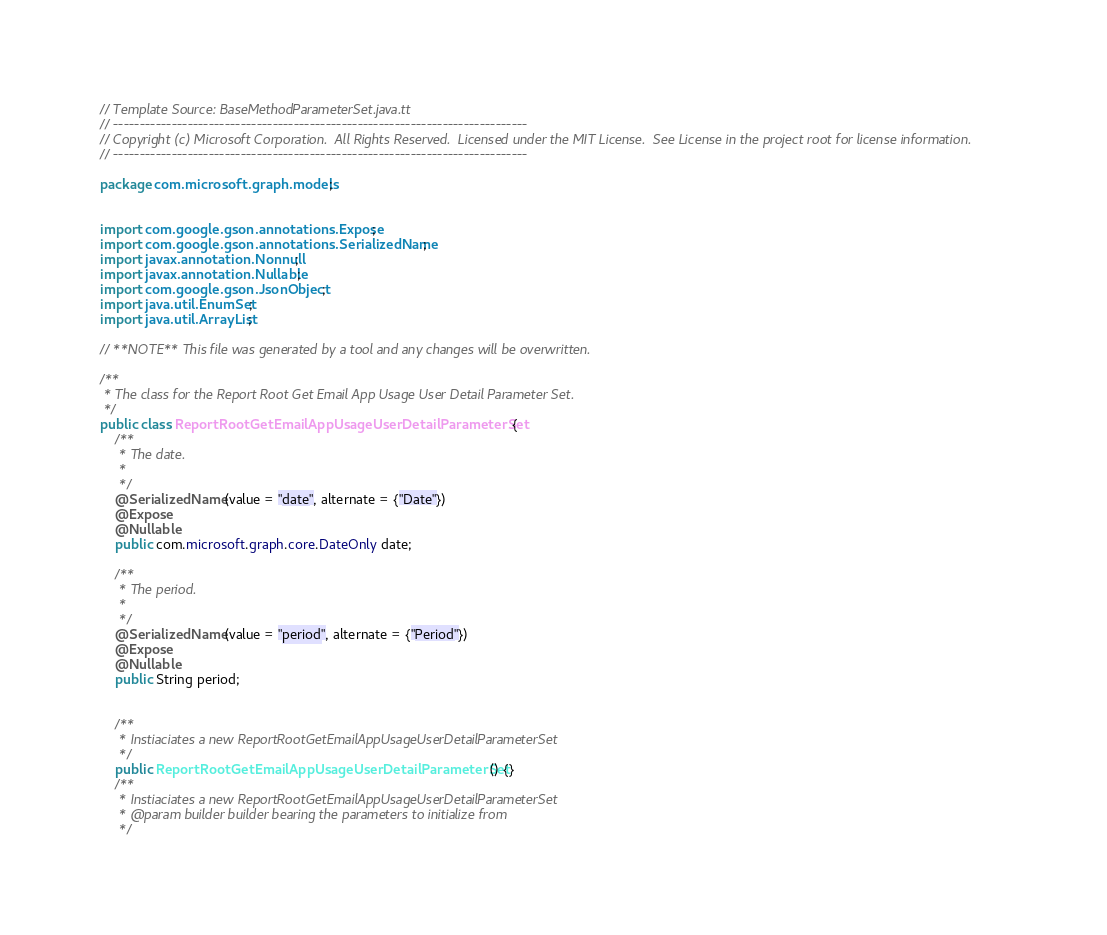Convert code to text. <code><loc_0><loc_0><loc_500><loc_500><_Java_>// Template Source: BaseMethodParameterSet.java.tt
// ------------------------------------------------------------------------------
// Copyright (c) Microsoft Corporation.  All Rights Reserved.  Licensed under the MIT License.  See License in the project root for license information.
// ------------------------------------------------------------------------------

package com.microsoft.graph.models;


import com.google.gson.annotations.Expose;
import com.google.gson.annotations.SerializedName;
import javax.annotation.Nonnull;
import javax.annotation.Nullable;
import com.google.gson.JsonObject;
import java.util.EnumSet;
import java.util.ArrayList;

// **NOTE** This file was generated by a tool and any changes will be overwritten.

/**
 * The class for the Report Root Get Email App Usage User Detail Parameter Set.
 */
public class ReportRootGetEmailAppUsageUserDetailParameterSet {
    /**
     * The date.
     * 
     */
    @SerializedName(value = "date", alternate = {"Date"})
    @Expose
	@Nullable
    public com.microsoft.graph.core.DateOnly date;

    /**
     * The period.
     * 
     */
    @SerializedName(value = "period", alternate = {"Period"})
    @Expose
	@Nullable
    public String period;


    /**
     * Instiaciates a new ReportRootGetEmailAppUsageUserDetailParameterSet
     */
    public ReportRootGetEmailAppUsageUserDetailParameterSet() {}
    /**
     * Instiaciates a new ReportRootGetEmailAppUsageUserDetailParameterSet
     * @param builder builder bearing the parameters to initialize from
     */</code> 